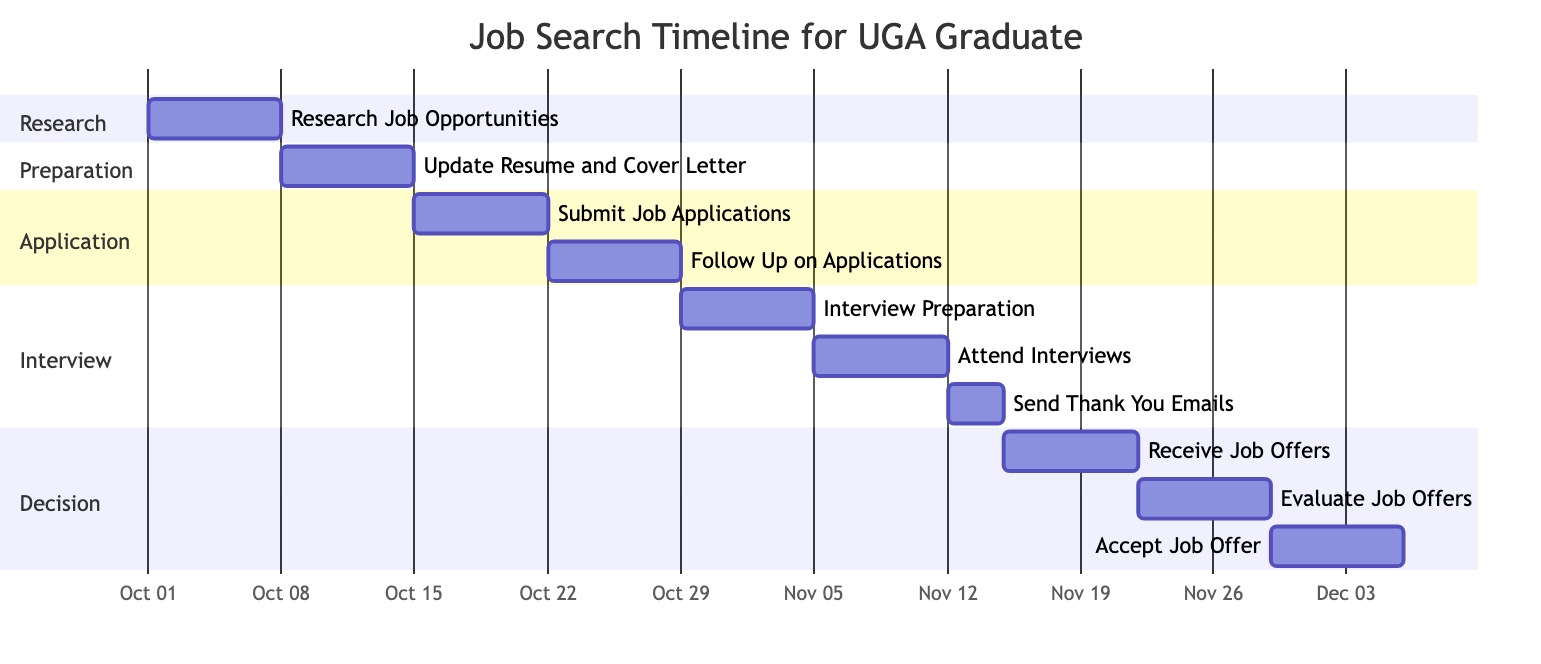What is the total number of tasks in the Gantt chart? The Gantt chart lists each task in sections. By counting the number of distinct tasks listed, we find that there are ten tasks in total: Research Job Opportunities, Update Resume and Cover Letter, Submit Job Applications, Follow Up on Applications, Interview Preparation, Attend Interviews, Send Thank You Emails, Receive Job Offers, Evaluate Job Offers, and Accept Job Offer.
Answer: 10 Which task occurs immediately after "Submit Job Applications"? The Gantt chart shows the timeline sequentially. After the task "Submit Job Applications" ends on October 21, the next task is "Follow Up on Applications," which begins on October 22. Therefore, the task that occurs immediately after is "Follow Up on Applications."
Answer: Follow Up on Applications What is the duration of the "Receive Job Offers" task? To determine the duration, we can subtract the start date from the end date. The "Receive Job Offers" task starts on November 15 and ends on November 21. This duration is calculated as 7 days (November 21 - November 15 + 1).
Answer: 7 days How many days are allocated for "Interview Preparation"? The "Interview Preparation" task starts on October 29 and ends on November 4. To find the duration, we count the days between October 29 and November 4, giving us a total of 7 days allocated for this task.
Answer: 7 days Which task spans from November 22 to November 28? By reviewing the tasks listed in the Gantt chart, we can see that the task scheduled to take place from November 22 to November 28 is "Evaluate Job Offers."
Answer: Evaluate Job Offers Is there any overlap between the tasks "Attend Interviews" and "Send Thank You Emails"? Analyzing the timelines, "Attend Interviews" runs from November 5 to November 11, while "Send Thank You Emails" runs from November 12 to November 14. Since "Send Thank You Emails" starts immediately after "Attend Interviews" finishes, there is no overlap between these tasks.
Answer: No Which section has the fewest tasks? Reviewing the divisions in the Gantt chart, the "Research" section has only one task, "Research Job Opportunities," while other sections have multiple tasks. Therefore, the section with the fewest tasks is "Research."
Answer: Research What is the last task scheduled in the diagram? To find the last task, we look at the end dates of all tasks. The task "Accept Job Offer" is scheduled to end on December 5, making it the last task in the timeline.
Answer: Accept Job Offer 